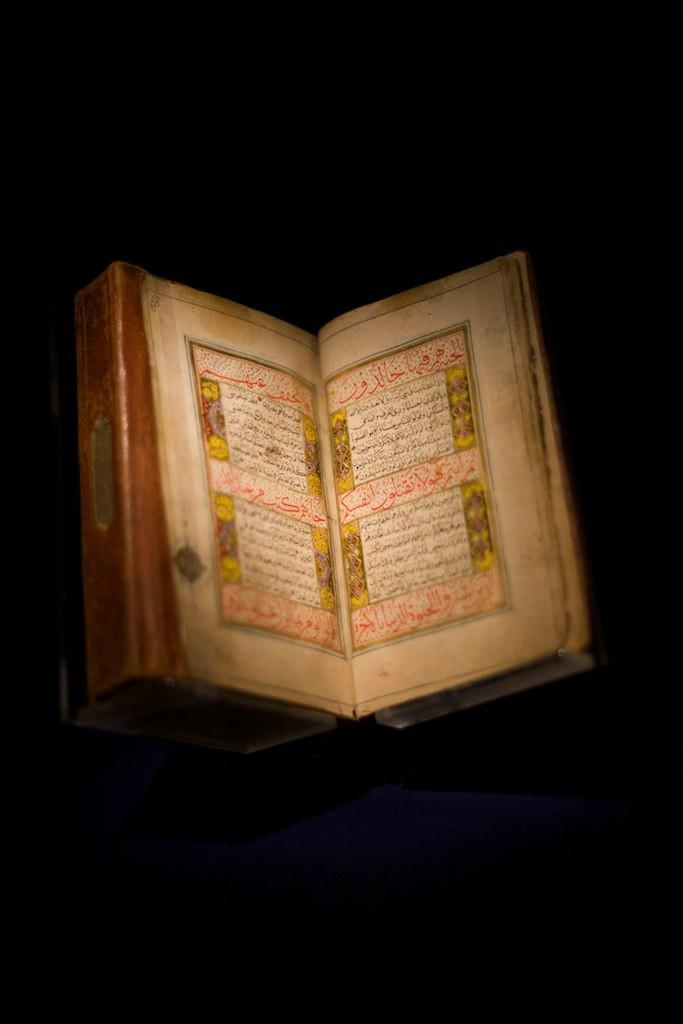What is the main object in the image? There is a book with text in the image. Can you describe the background of the image? The background of the image is dark. What type of rifle is being tested in the image? There is no rifle present in the image; it features a book with text and a dark background. 